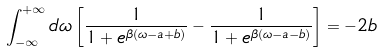Convert formula to latex. <formula><loc_0><loc_0><loc_500><loc_500>\int _ { - \infty } ^ { + \infty } d \omega \left [ \frac { 1 } { 1 + e ^ { \beta ( \omega - a + b ) } } - \frac { 1 } { 1 + e ^ { \beta ( \omega - a - b ) } } \right ] = - 2 b</formula> 